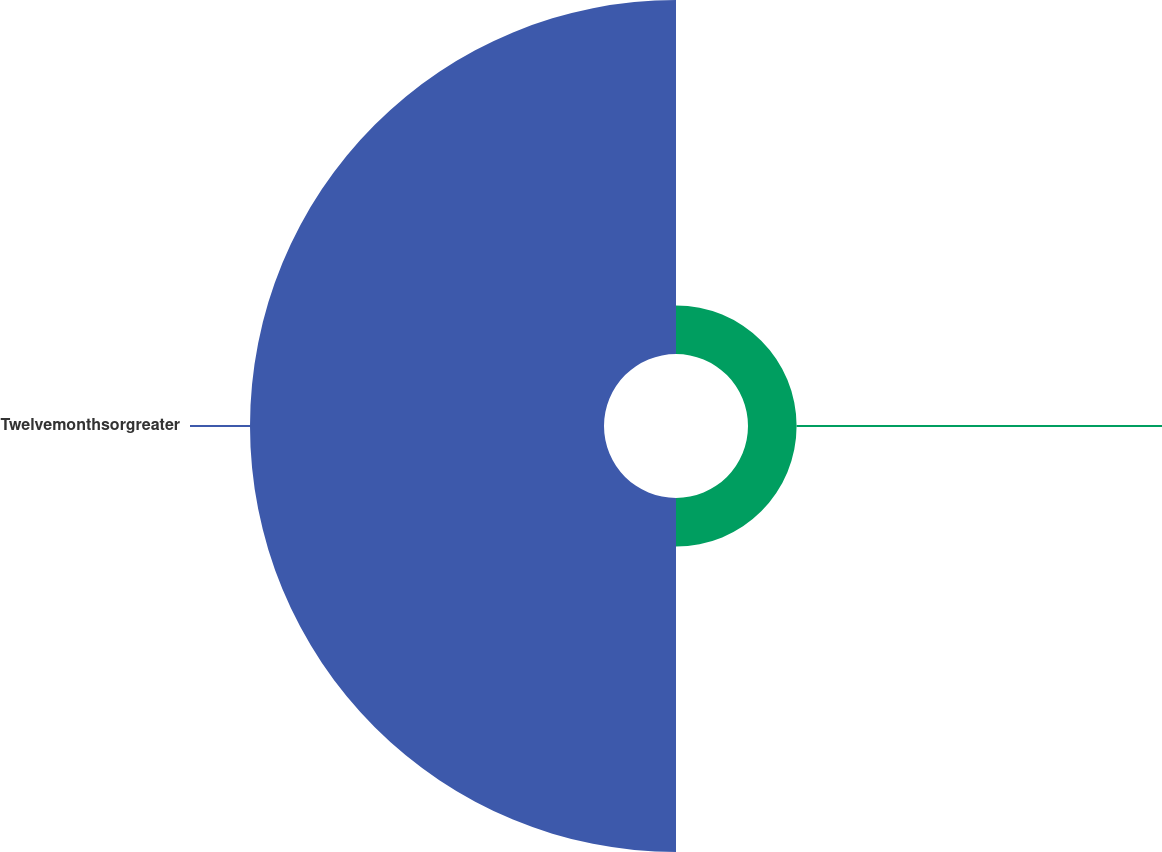Convert chart. <chart><loc_0><loc_0><loc_500><loc_500><pie_chart><ecel><fcel>Twelvemonthsorgreater<nl><fcel>12.07%<fcel>87.93%<nl></chart> 